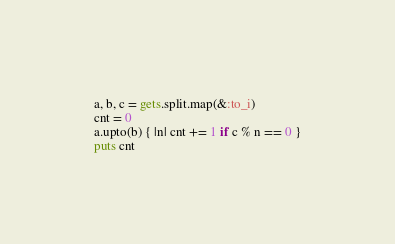<code> <loc_0><loc_0><loc_500><loc_500><_Ruby_>a, b, c = gets.split.map(&:to_i)
cnt = 0
a.upto(b) { |n| cnt += 1 if c % n == 0 }
puts cnt</code> 